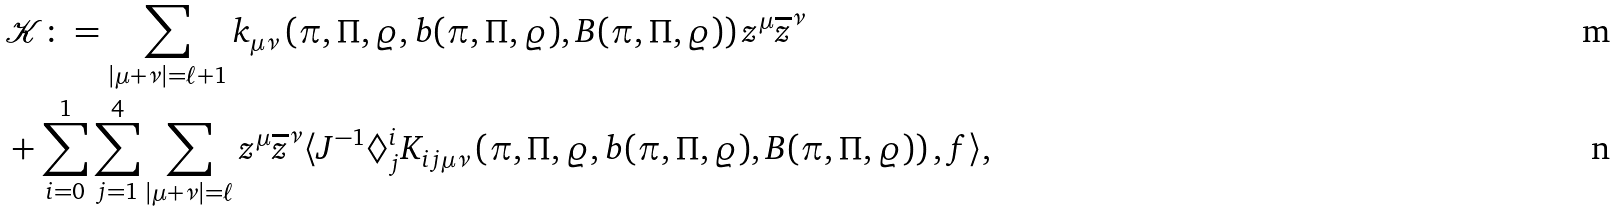Convert formula to latex. <formula><loc_0><loc_0><loc_500><loc_500>& \mathcal { K } \colon = \sum _ { | \mu + \nu | = \ell + 1 } { k } _ { \mu \nu } \left ( \pi , \Pi , \varrho , b ( \pi , \Pi , \varrho ) , B ( \pi , \Pi , \varrho ) \right ) z ^ { \mu } \overline { z } ^ { \nu } \\ & + \sum _ { i = 0 } ^ { 1 } \sum _ { j = 1 } ^ { 4 } \sum _ { | \mu + \nu | = \ell } z ^ { \mu } \overline { z } ^ { \nu } \langle J ^ { - 1 } \Diamond ^ { i } _ { j } K _ { i j \mu \nu } \left ( \pi , \Pi , \varrho , b ( \pi , \Pi , \varrho ) , B ( \pi , \Pi , \varrho ) \right ) , f \rangle ,</formula> 